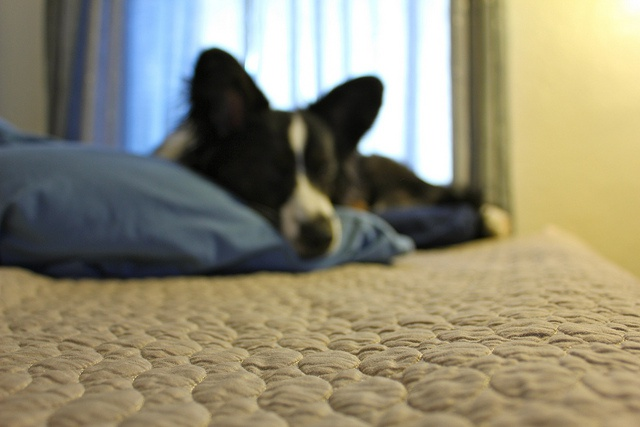Describe the objects in this image and their specific colors. I can see bed in gray and tan tones and dog in gray, black, darkgreen, and tan tones in this image. 